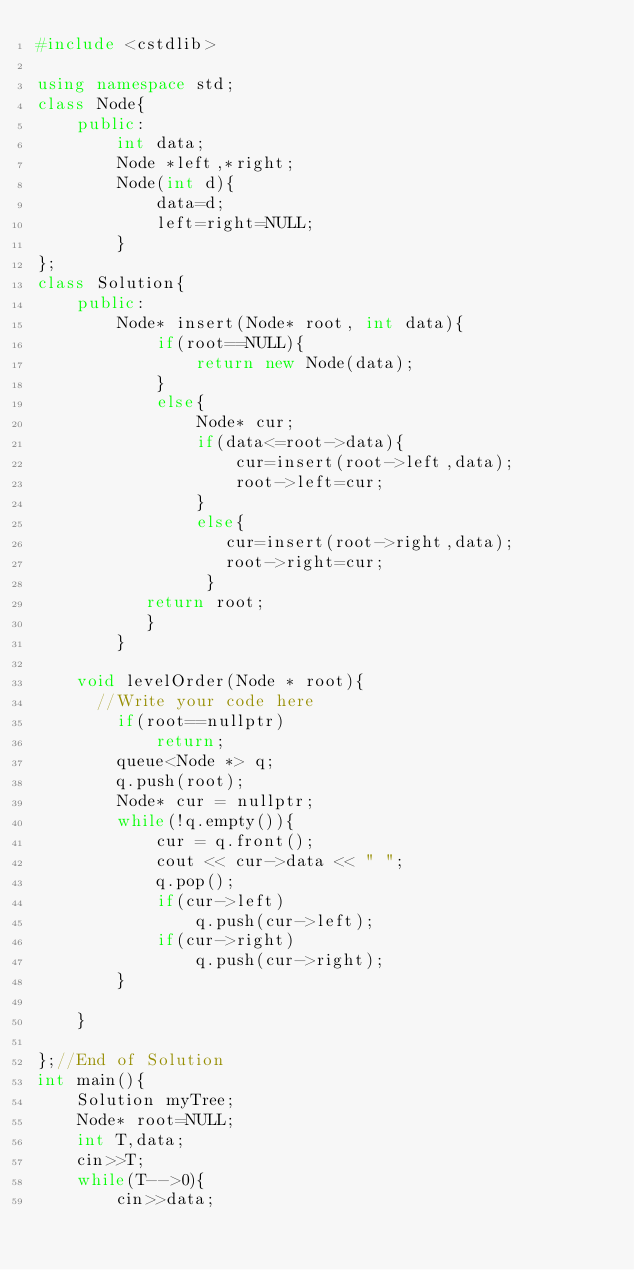Convert code to text. <code><loc_0><loc_0><loc_500><loc_500><_C++_>#include <cstdlib>

using namespace std;    
class Node{
    public:
        int data;
        Node *left,*right;
        Node(int d){
            data=d;
            left=right=NULL;
        }
};
class Solution{
    public:
        Node* insert(Node* root, int data){
            if(root==NULL){
                return new Node(data);
            }
            else{
                Node* cur;
                if(data<=root->data){
                    cur=insert(root->left,data);
                    root->left=cur;
                }
                else{
                   cur=insert(root->right,data);
                   root->right=cur;
                 }           
           return root;
           }
        }

    void levelOrder(Node * root){
      //Write your code here
        if(root==nullptr)
            return;
        queue<Node *> q;
        q.push(root);
        Node* cur = nullptr;
        while(!q.empty()){
            cur = q.front();
            cout << cur->data << " ";
            q.pop();
            if(cur->left)
                q.push(cur->left);
            if(cur->right)
                q.push(cur->right);
        }
  
    }

};//End of Solution
int main(){
    Solution myTree;
    Node* root=NULL;
    int T,data;
    cin>>T;
    while(T-->0){
        cin>>data;</code> 